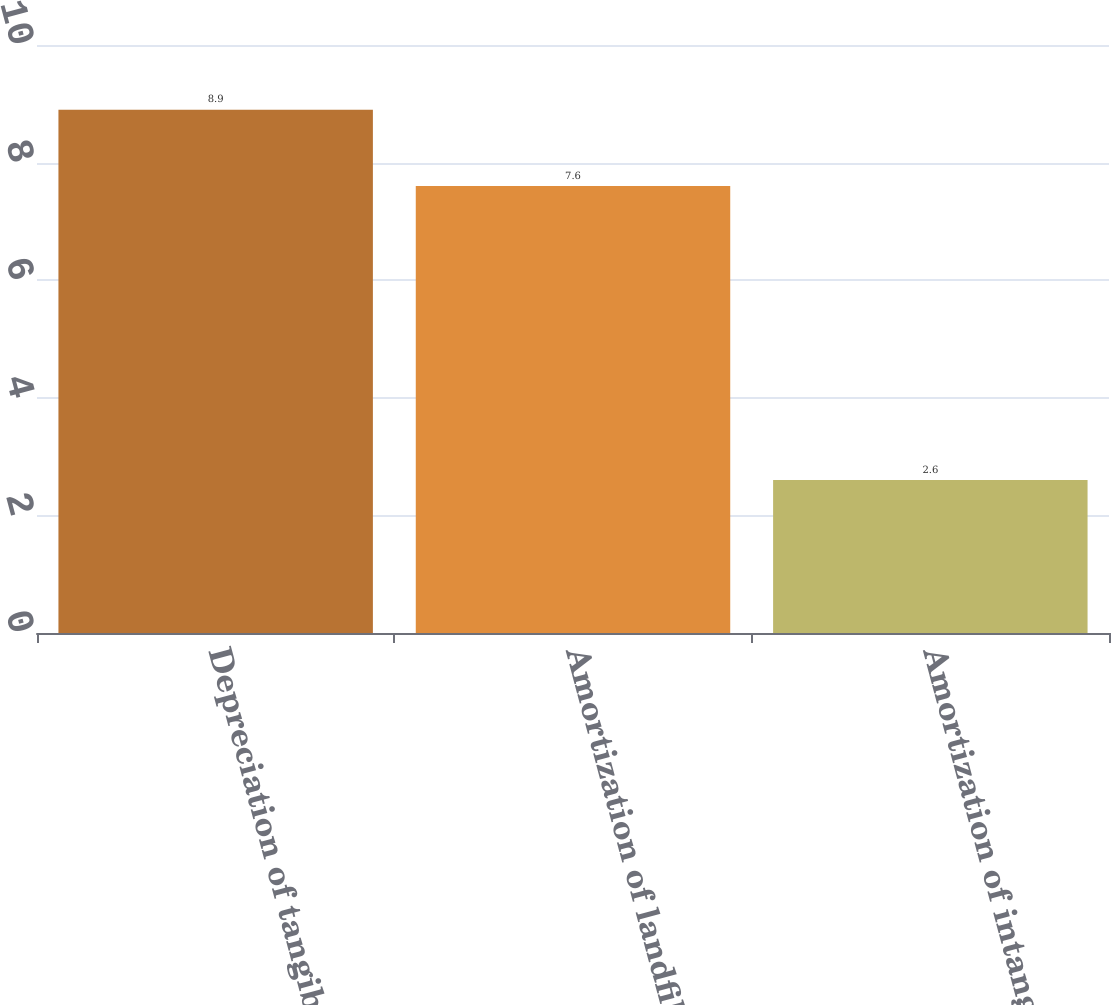Convert chart. <chart><loc_0><loc_0><loc_500><loc_500><bar_chart><fcel>Depreciation of tangible<fcel>Amortization of landfill<fcel>Amortization of intangible<nl><fcel>8.9<fcel>7.6<fcel>2.6<nl></chart> 